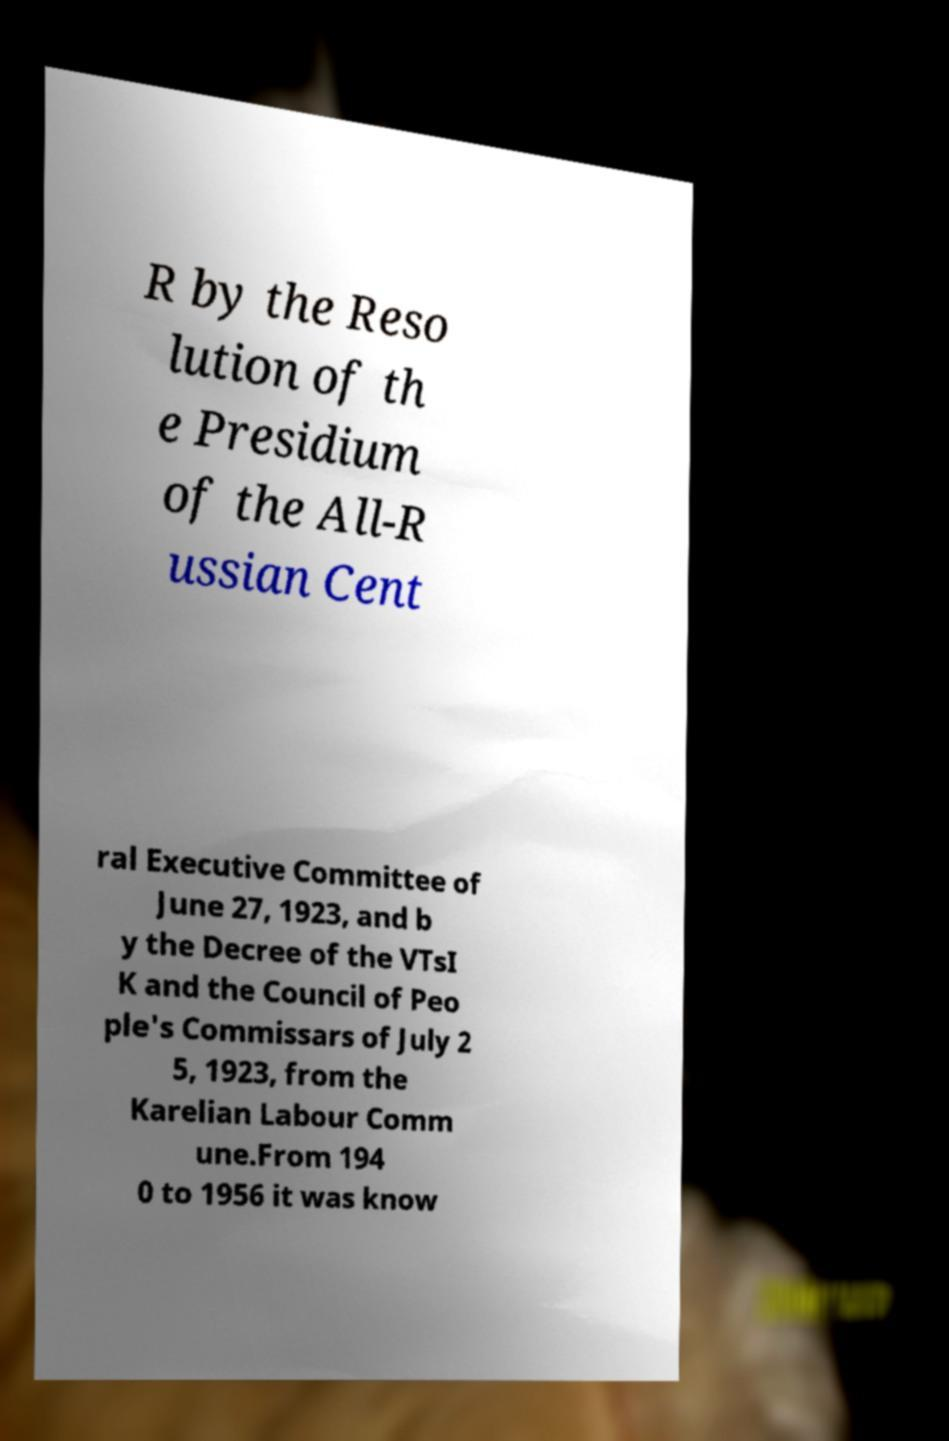For documentation purposes, I need the text within this image transcribed. Could you provide that? R by the Reso lution of th e Presidium of the All-R ussian Cent ral Executive Committee of June 27, 1923, and b y the Decree of the VTsI K and the Council of Peo ple's Commissars of July 2 5, 1923, from the Karelian Labour Comm une.From 194 0 to 1956 it was know 